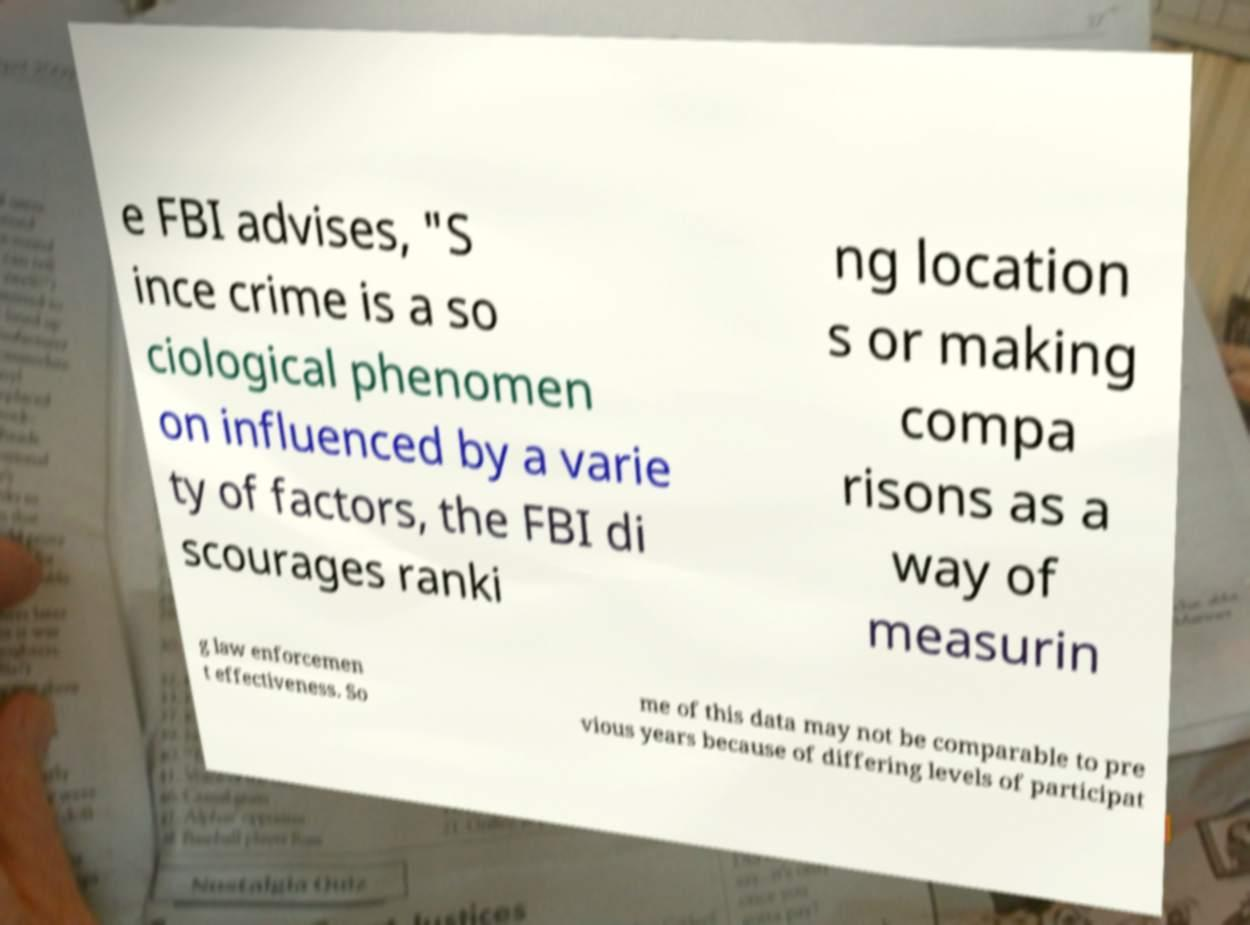What messages or text are displayed in this image? I need them in a readable, typed format. e FBI advises, "S ince crime is a so ciological phenomen on influenced by a varie ty of factors, the FBI di scourages ranki ng location s or making compa risons as a way of measurin g law enforcemen t effectiveness. So me of this data may not be comparable to pre vious years because of differing levels of participat 